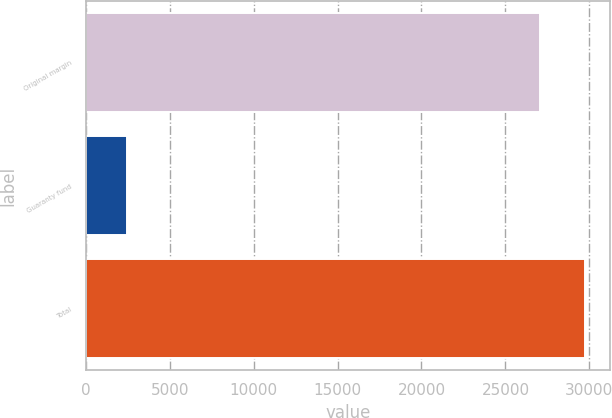Convert chart to OTSL. <chart><loc_0><loc_0><loc_500><loc_500><bar_chart><fcel>Original margin<fcel>Guaranty fund<fcel>Total<nl><fcel>27046<fcel>2444<fcel>29750.6<nl></chart> 